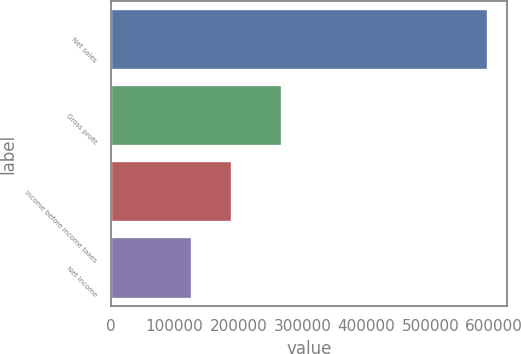Convert chart to OTSL. <chart><loc_0><loc_0><loc_500><loc_500><bar_chart><fcel>Net sales<fcel>Gross profit<fcel>Income before income taxes<fcel>Net income<nl><fcel>590980<fcel>267241<fcel>189016<fcel>126872<nl></chart> 